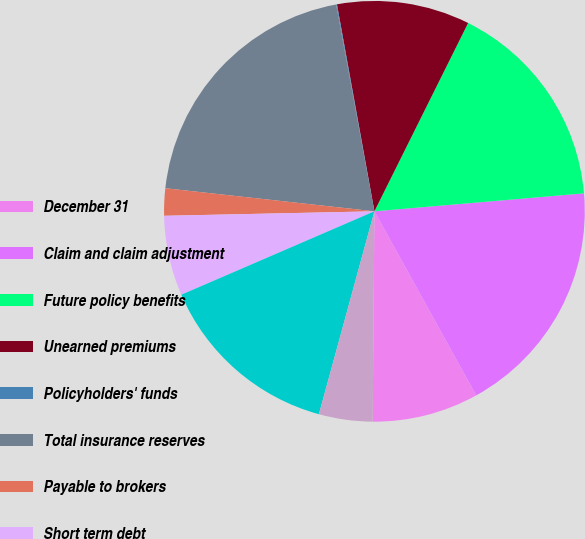Convert chart. <chart><loc_0><loc_0><loc_500><loc_500><pie_chart><fcel>December 31<fcel>Claim and claim adjustment<fcel>Future policy benefits<fcel>Unearned premiums<fcel>Policyholders' funds<fcel>Total insurance reserves<fcel>Payable to brokers<fcel>Short term debt<fcel>Long term debt<fcel>Deferred incomes taxes<nl><fcel>8.17%<fcel>18.32%<fcel>16.29%<fcel>10.2%<fcel>0.06%<fcel>20.34%<fcel>2.09%<fcel>6.15%<fcel>14.26%<fcel>4.12%<nl></chart> 